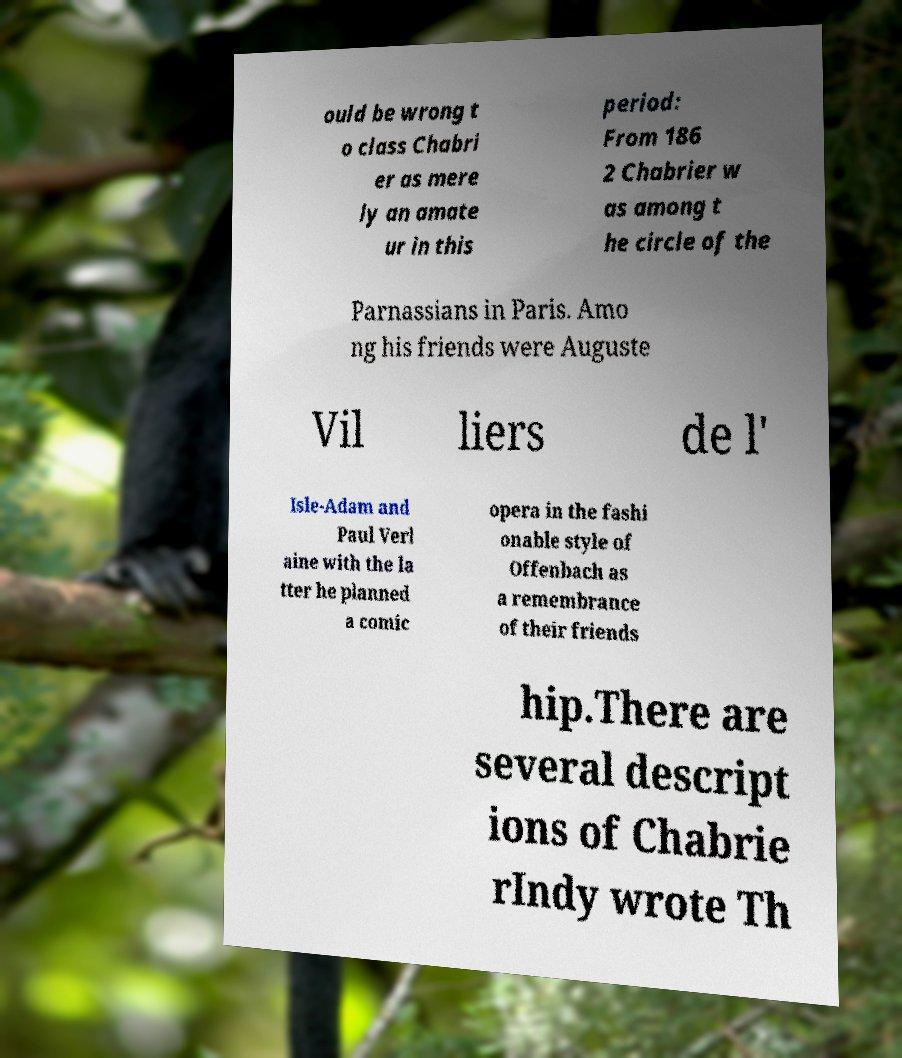I need the written content from this picture converted into text. Can you do that? ould be wrong t o class Chabri er as mere ly an amate ur in this period: From 186 2 Chabrier w as among t he circle of the Parnassians in Paris. Amo ng his friends were Auguste Vil liers de l' Isle-Adam and Paul Verl aine with the la tter he planned a comic opera in the fashi onable style of Offenbach as a remembrance of their friends hip.There are several descript ions of Chabrie rIndy wrote Th 